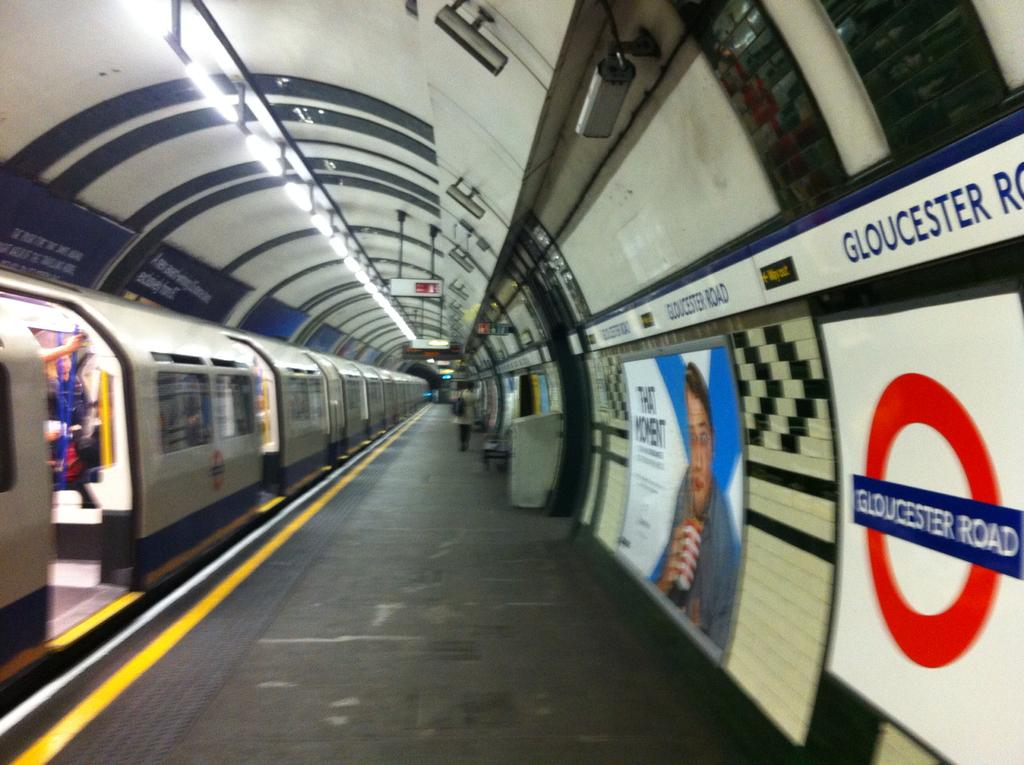Provide a one-sentence caption for the provided image. A subway train park beside a walkway with a Gloucester on the wall. 